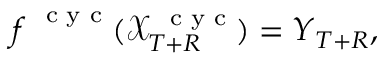Convert formula to latex. <formula><loc_0><loc_0><loc_500><loc_500>\boldsymbol f ^ { c y c } ( \mathcal { X } _ { T + R } ^ { c y c } ) = \boldsymbol Y _ { T + R } ,</formula> 